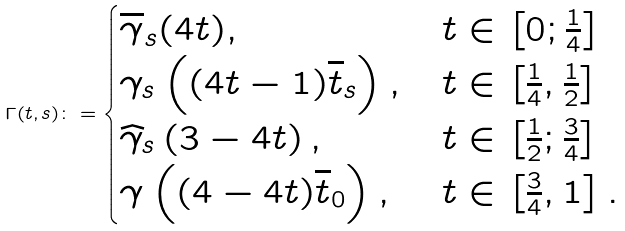<formula> <loc_0><loc_0><loc_500><loc_500>\Gamma ( t , s ) \colon = \begin{cases} \overline { \gamma } _ { s } ( 4 t ) , & t \in \left [ 0 ; \frac { 1 } 4 \right ] \\ \gamma _ { s } \left ( ( 4 t - 1 ) \overline { t } _ { s } \right ) , & t \in \left [ \frac { 1 } 4 , \frac { 1 } 2 \right ] \\ \widehat { \gamma } _ { s } \left ( 3 - 4 t \right ) , & t \in \left [ \frac { 1 } 2 ; \frac { 3 } 4 \right ] \\ \gamma \left ( ( 4 - 4 t ) \overline { t } _ { 0 } \right ) , & t \in \left [ \frac { 3 } 4 , 1 \right ] . \end{cases}</formula> 